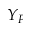<formula> <loc_0><loc_0><loc_500><loc_500>Y _ { F }</formula> 